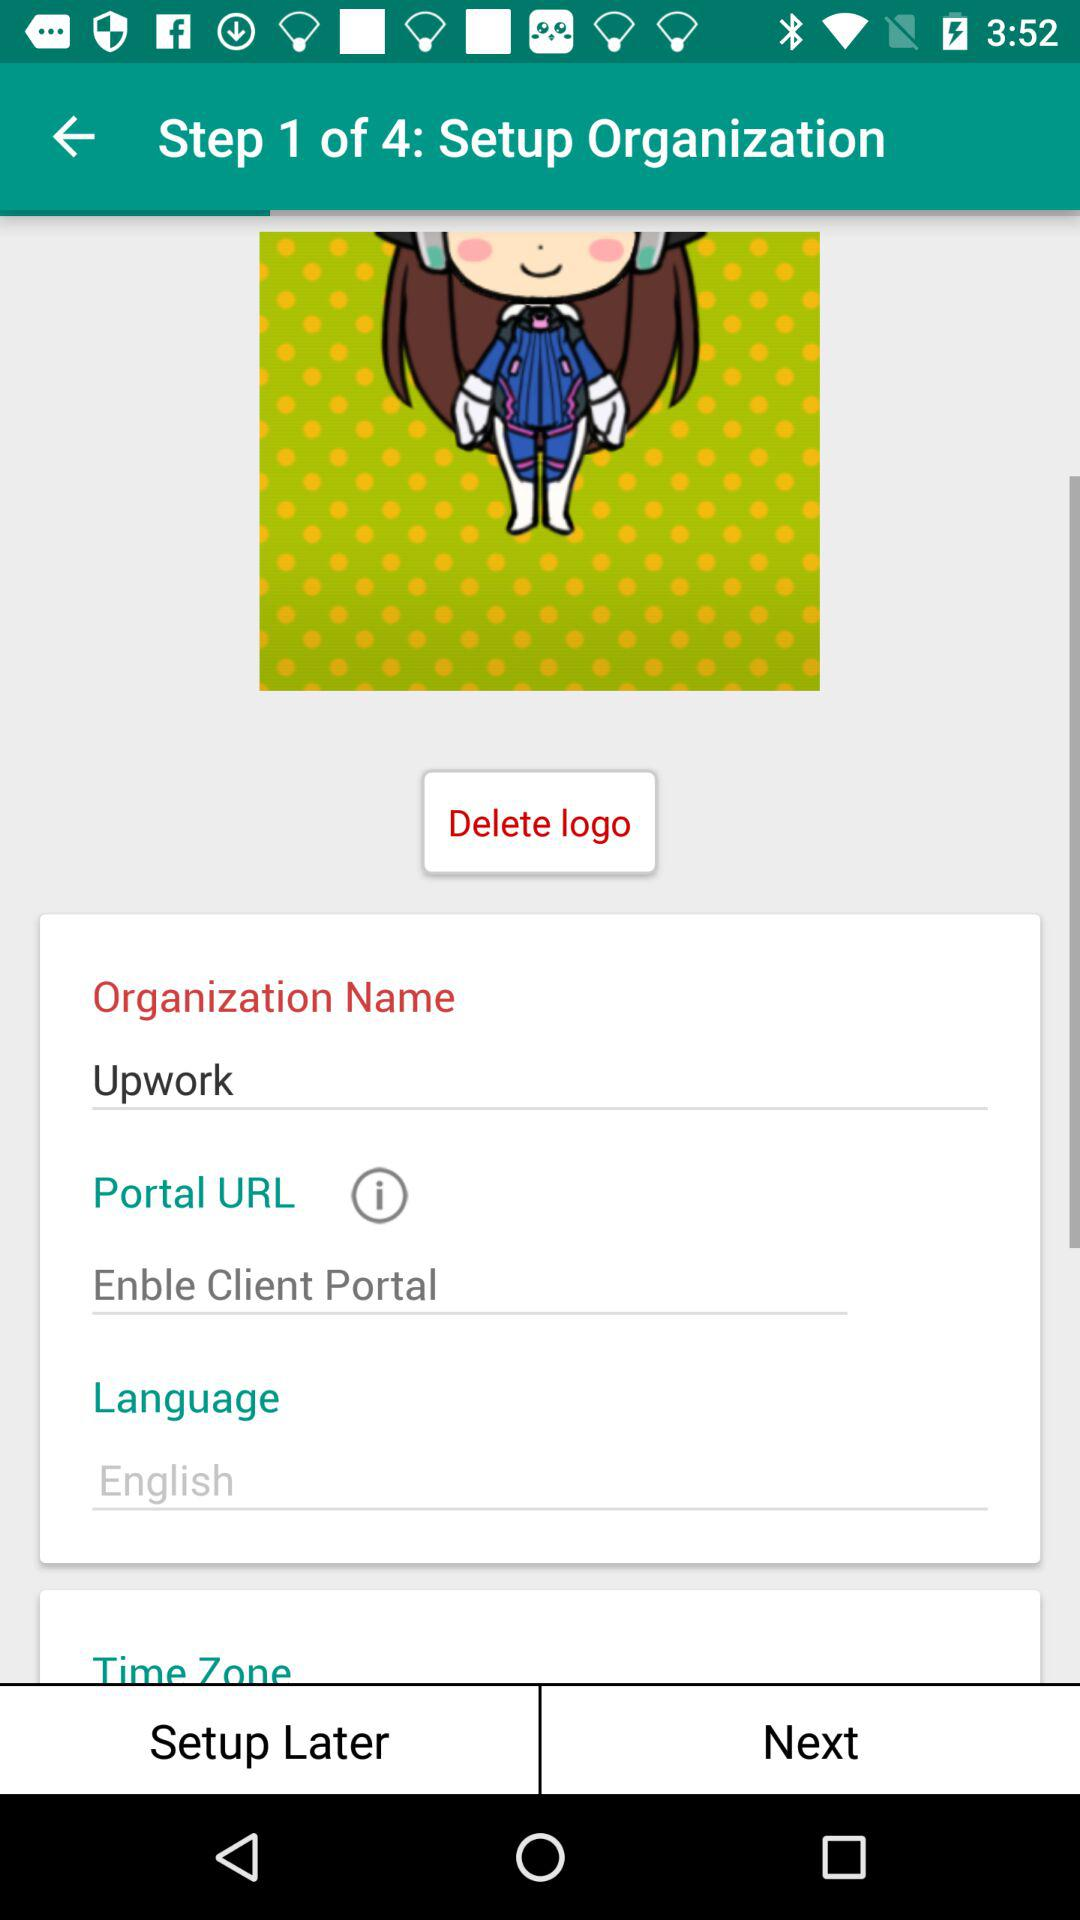How many total steps are there to set up the organization? There are 4 steps in total. 